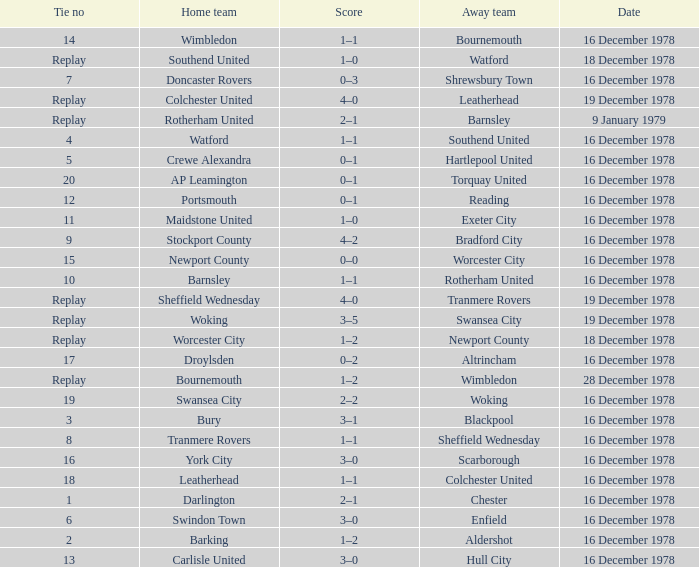Waht was the away team when the home team is colchester united? Leatherhead. 